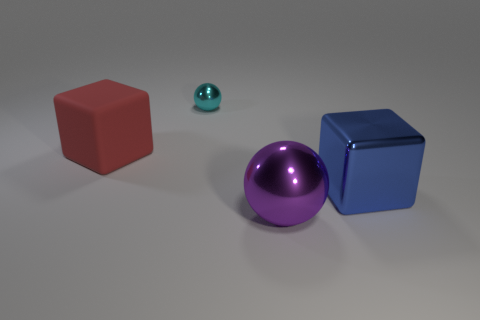Can you describe the texture of the objects' surfaces? The objects' surfaces appear to be smooth and somewhat reflective, suggesting a metallic or plastic material. The lighting highlights their glossy finishes. 